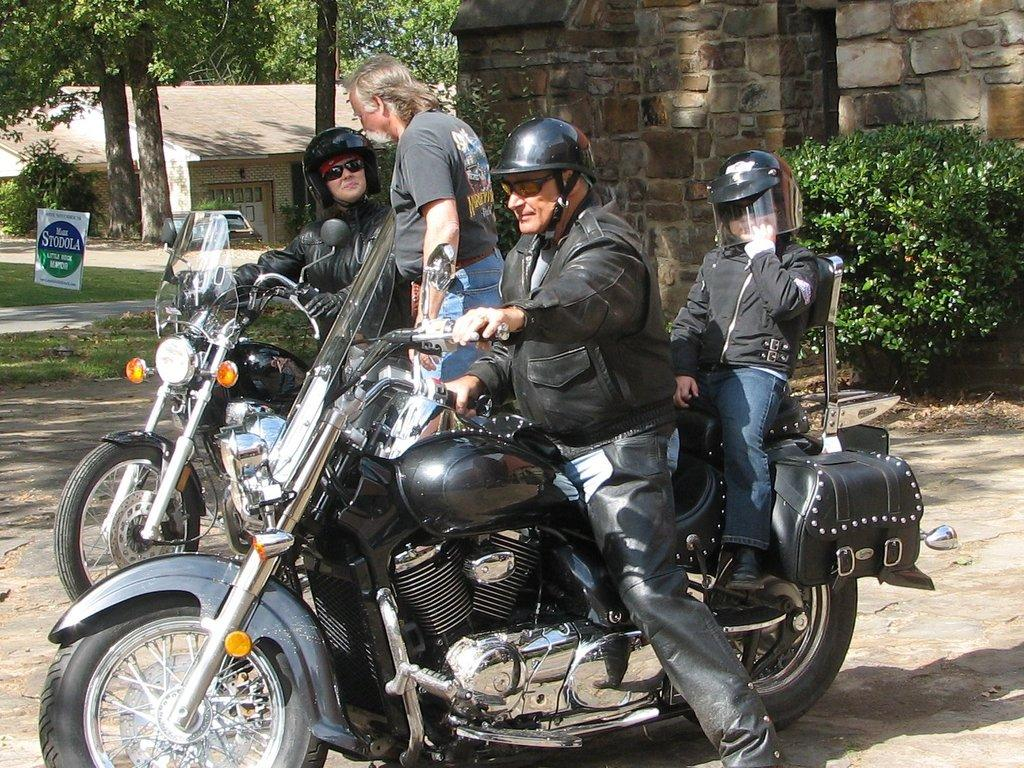How many people are in the image? There are four persons in the image. What objects are associated with the persons in the image? There are two bikes in the image. What type of terrain is visible in the image? There is grass in the image. What is the board used for in the image? The purpose of the board is not clear from the facts provided. What celestial bodies can be seen in the image? Planets are visible in the image. What type of structures are present in the image? Houses are present in the image. What type of vegetation is visible in the image? Trees are visible in the image. What word is being advertised on the bikes in the image? There is no information about any advertisement or word on the bikes in the image. What color are the eyes of the persons in the image? The facts provided do not mention the color of anyone's eyes in the image. 